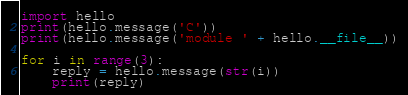Convert code to text. <code><loc_0><loc_0><loc_500><loc_500><_Python_>import hello
print(hello.message('C'))
print(hello.message('module ' + hello.__file__))

for i in range(3):
    reply = hello.message(str(i))
    print(reply)
</code> 